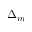<formula> <loc_0><loc_0><loc_500><loc_500>\Delta _ { m }</formula> 